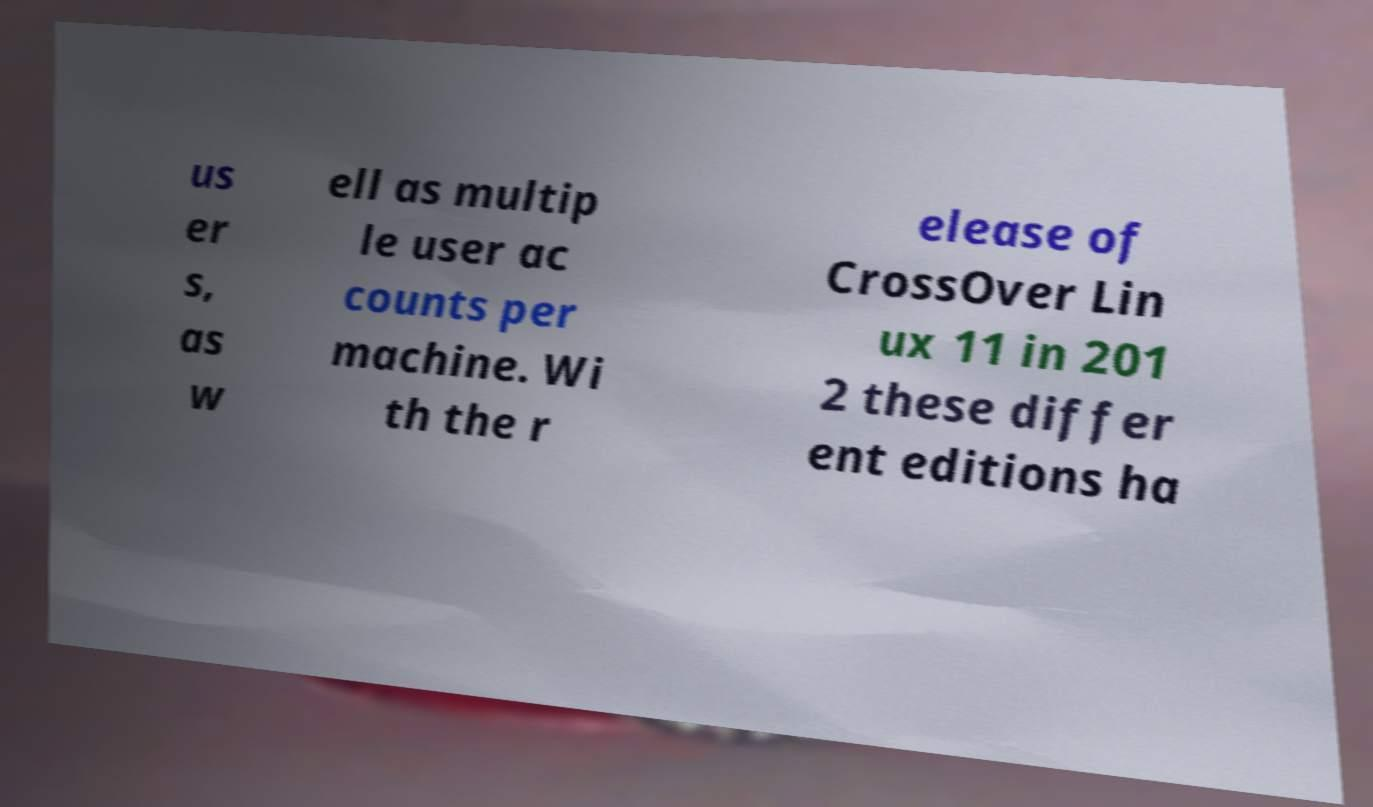I need the written content from this picture converted into text. Can you do that? us er s, as w ell as multip le user ac counts per machine. Wi th the r elease of CrossOver Lin ux 11 in 201 2 these differ ent editions ha 